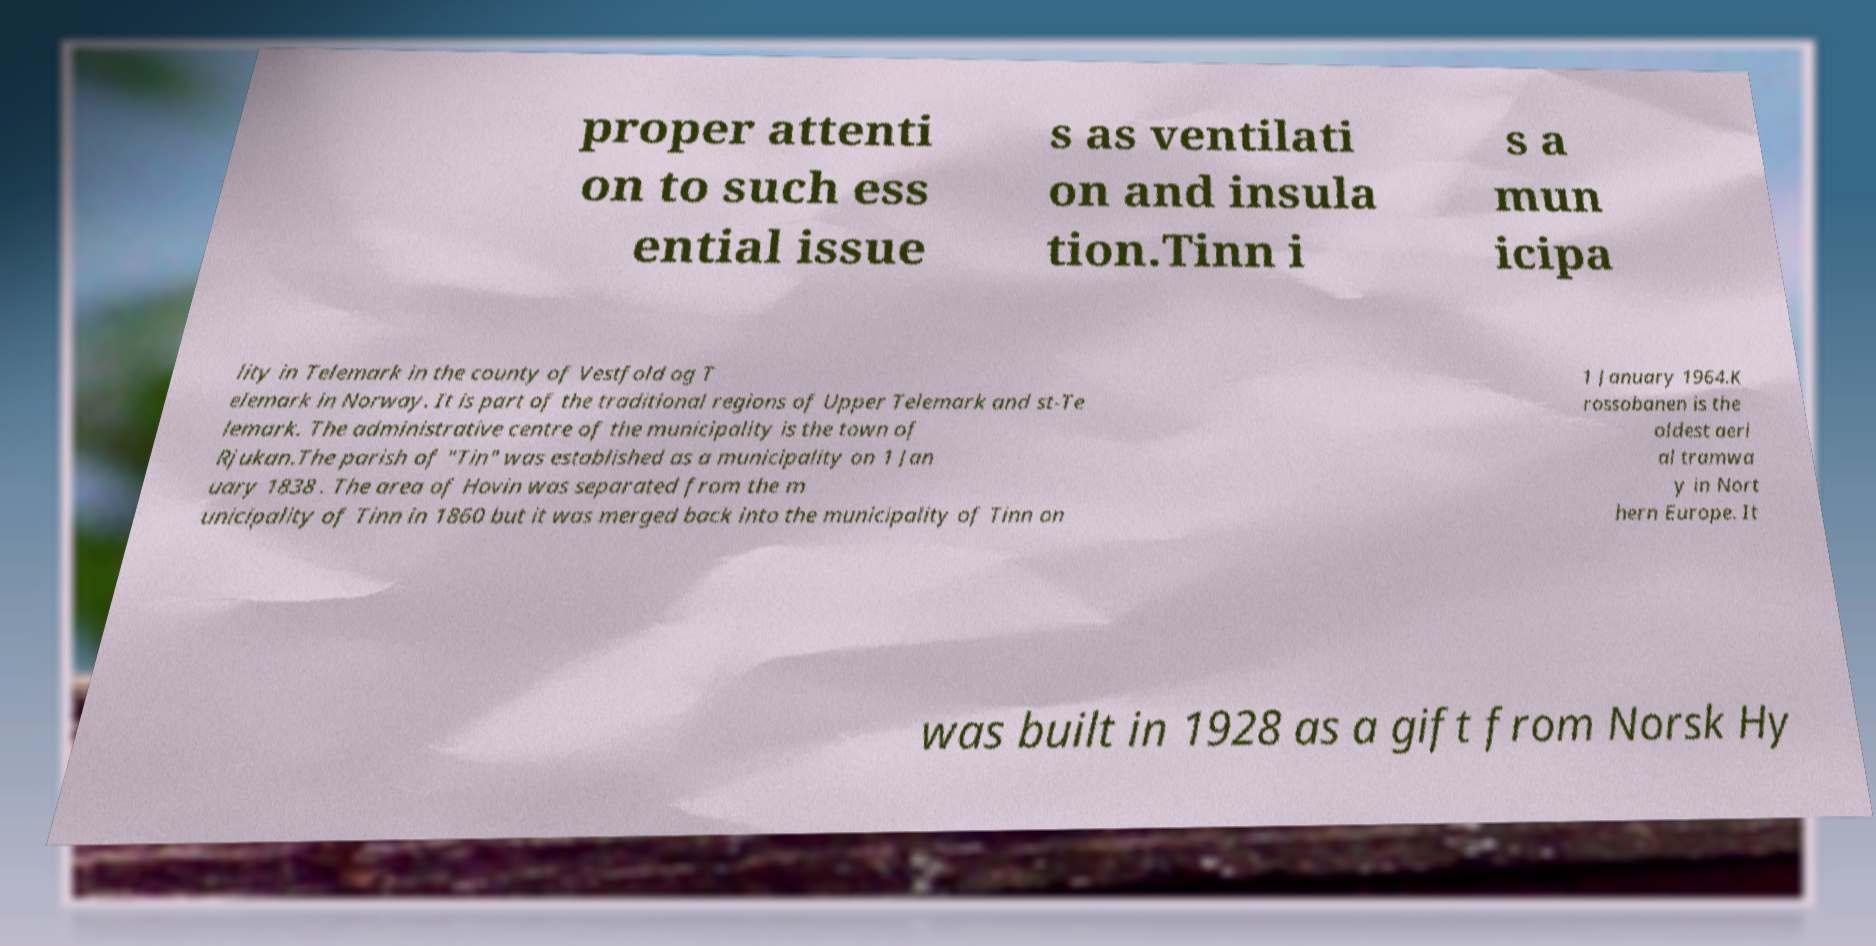Can you read and provide the text displayed in the image?This photo seems to have some interesting text. Can you extract and type it out for me? proper attenti on to such ess ential issue s as ventilati on and insula tion.Tinn i s a mun icipa lity in Telemark in the county of Vestfold og T elemark in Norway. It is part of the traditional regions of Upper Telemark and st-Te lemark. The administrative centre of the municipality is the town of Rjukan.The parish of "Tin" was established as a municipality on 1 Jan uary 1838 . The area of Hovin was separated from the m unicipality of Tinn in 1860 but it was merged back into the municipality of Tinn on 1 January 1964.K rossobanen is the oldest aeri al tramwa y in Nort hern Europe. It was built in 1928 as a gift from Norsk Hy 